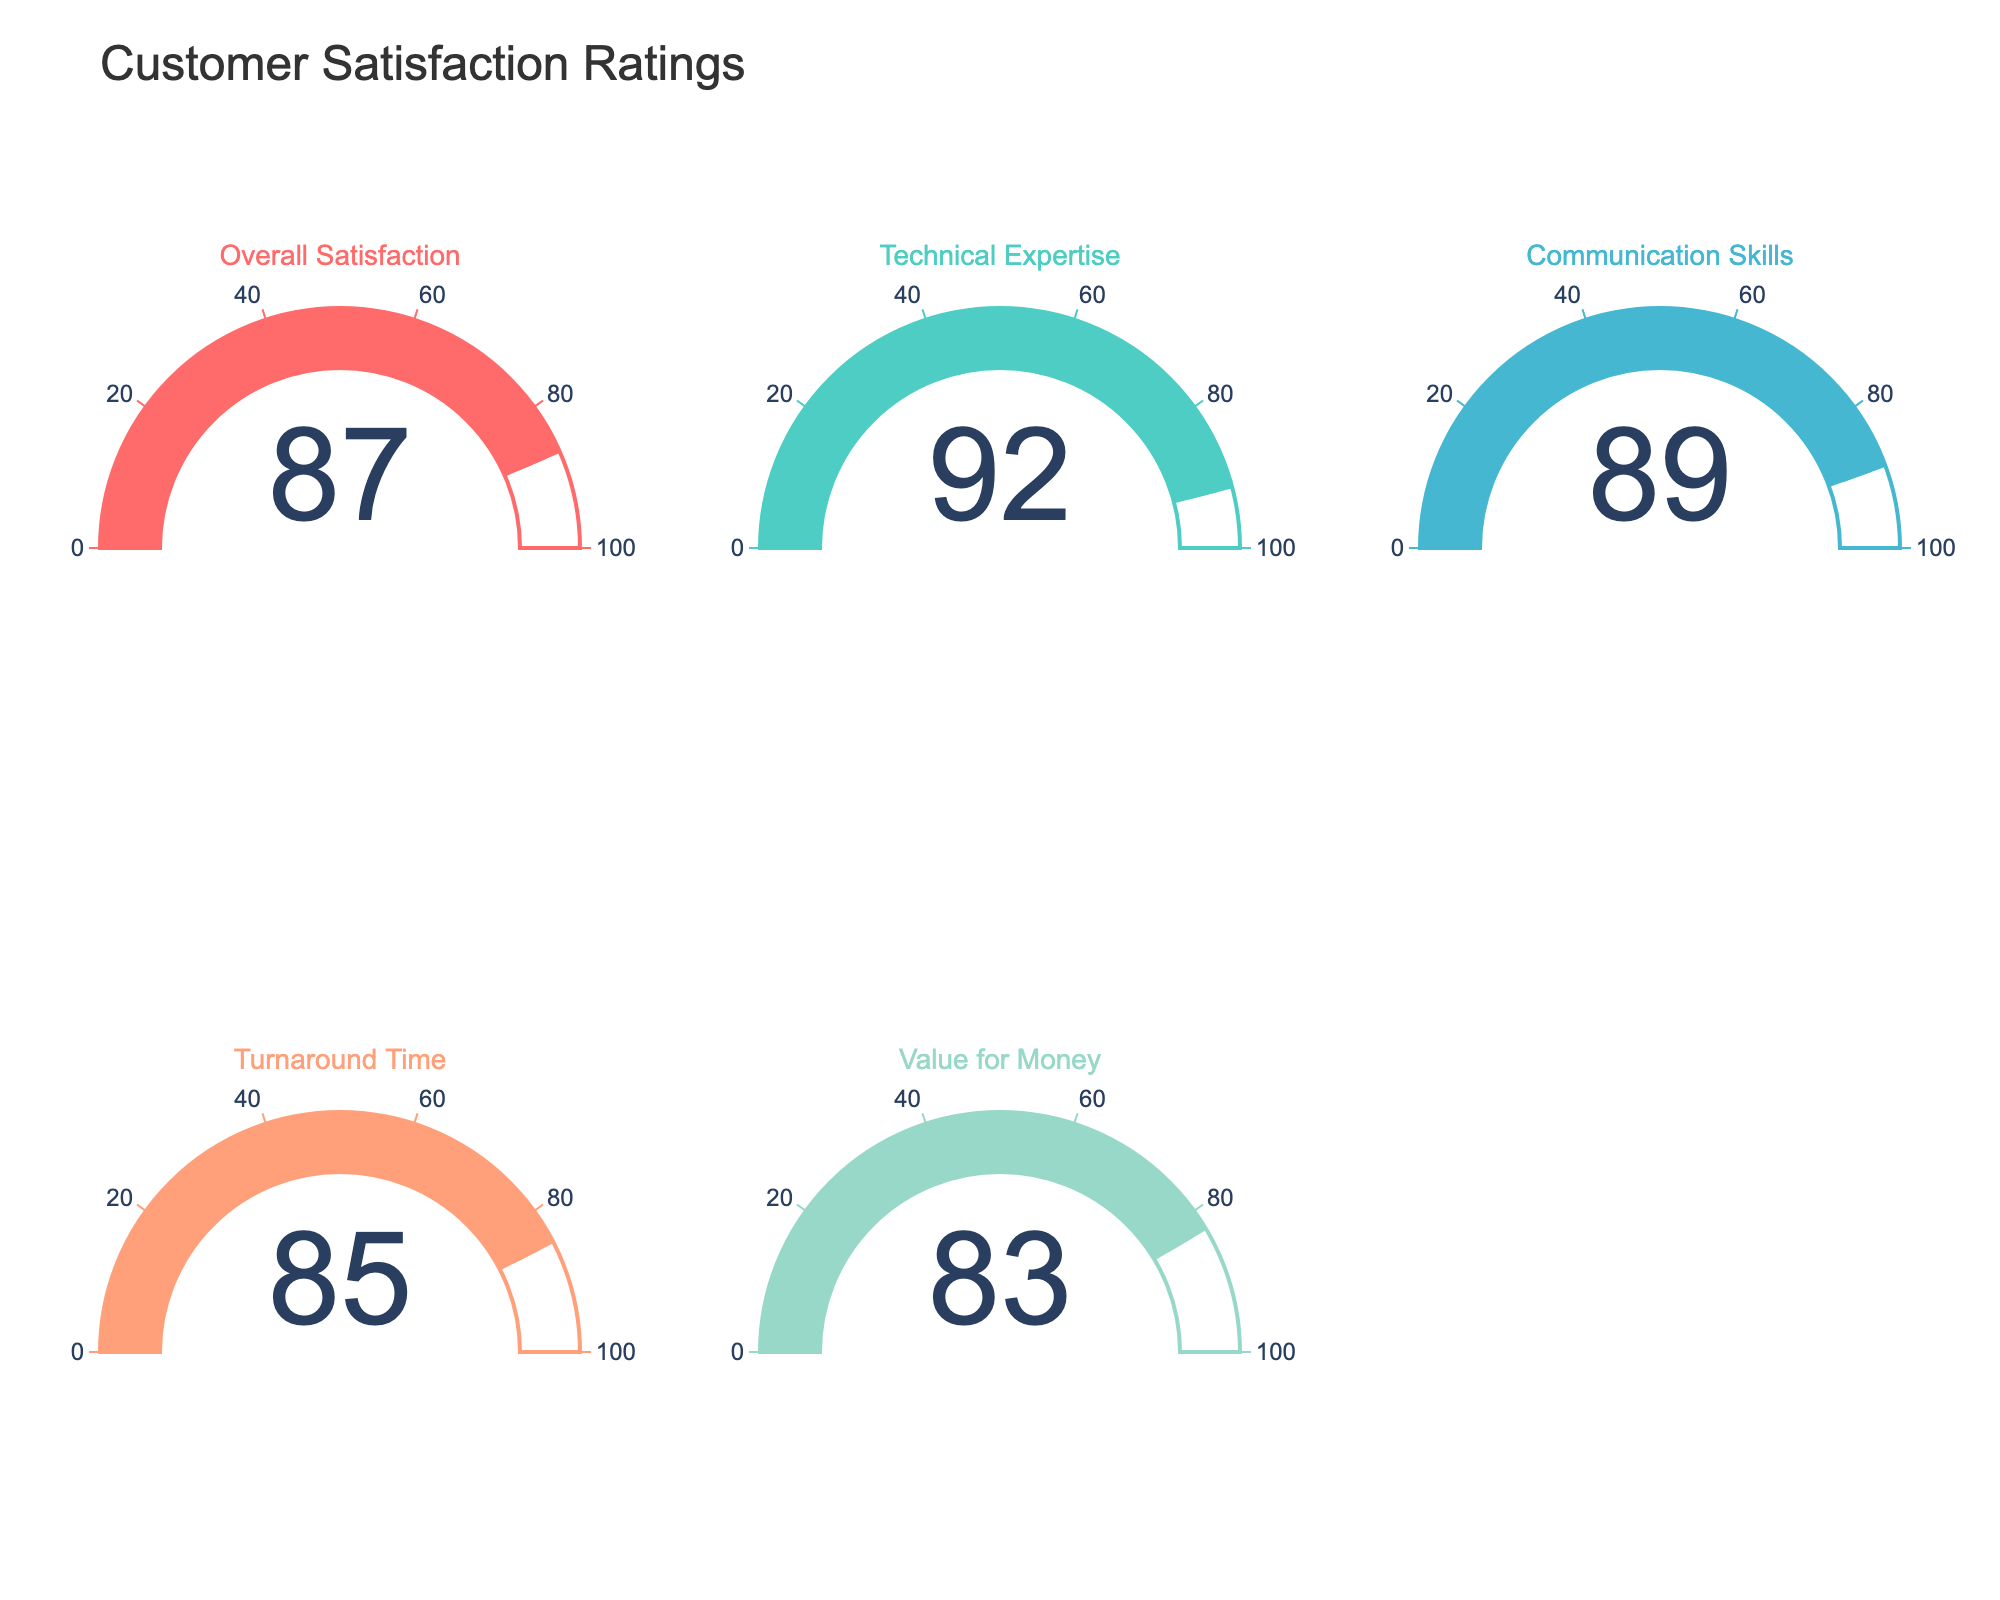How many gauge charts are there in total? The visual shows five gauge charts across two rows and three columns. The sixth slot is empty.
Answer: 5 What is the customer satisfaction rating for communication skills? The gauge chart labeled "Communication Skills" shows a rating of 89.
Answer: 89 Which category has the lowest satisfaction rating? By comparing all the gauges, the gauge labeled "Value for Money" has the lowest rating, which is 83.
Answer: Value for Money What is the difference between the highest and lowest customer satisfaction ratings? The highest rating is 92 (Technical Expertise) and the lowest is 83 (Value for Money). The difference is 92 - 83.
Answer: 9 Which category is rated higher, technical expertise or turnaround time? Comparing the gauges, "Technical Expertise" has a rating of 92, and "Turnaround Time" has a rating of 85.
Answer: Technical Expertise What is the average satisfaction rating across all categories? The ratings are 87, 92, 89, 85, and 83. Their sum is 87 + 92 + 89 + 85 + 83 = 436. Dividing by 5, the average rating is 87.2.
Answer: 87.2 Which two categories have ratings closest to each other, and what are their values? The categories "Overall Satisfaction" and "Communication Skills" have ratings of 87 and 89 respectively. The difference is 2, the smallest among all pairs.
Answer: Overall Satisfaction and Communication Skills What is the total satisfaction rating when combining the "Overall Satisfaction" and "Turnaround Time" scores? The ratings are 87 (Overall Satisfaction) and 85 (Turnaround Time). The total is 87 + 85.
Answer: 172 What color represents the gauge for "Value for Money"? The gauge for "Value for Money" is represented in a light green color.
Answer: light green 